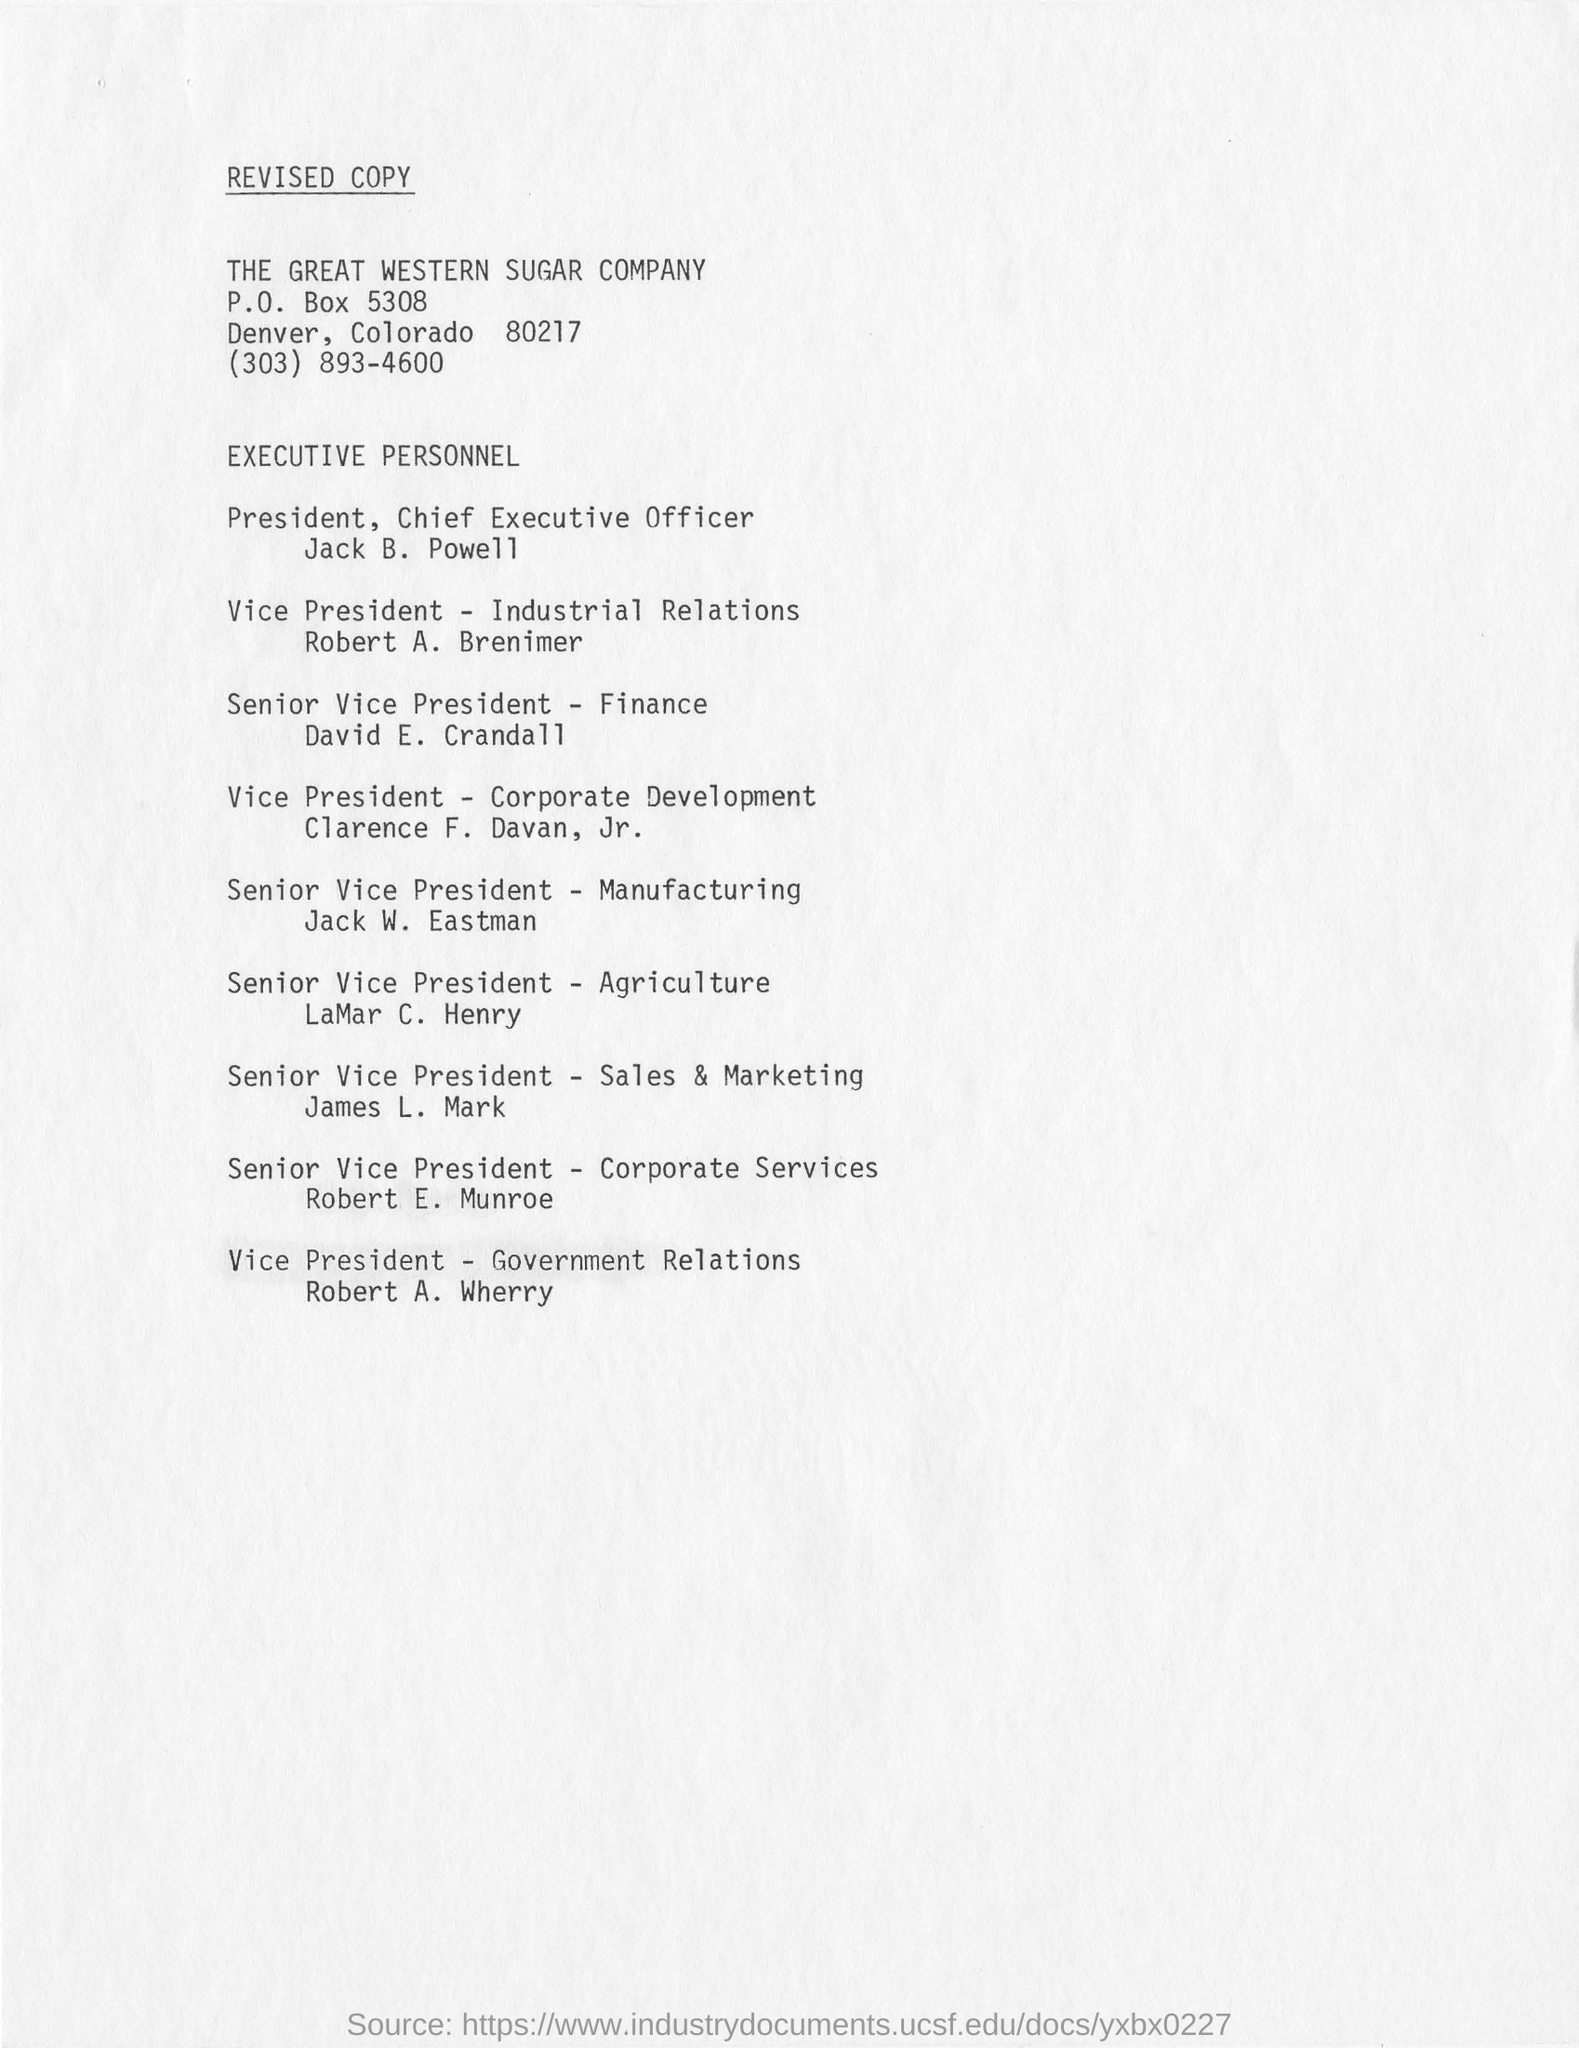Who is the senior vice president -finance ?
Your answer should be compact. David E. Crandall. Jack w. eastman the senior vice president belongs to which trade ?
Your answer should be compact. Manufacturing. Who is the vice president of corporate development ?
Provide a short and direct response. Clarence F. Davan, Jr. Who is the vice president of government relations ?
Provide a succinct answer. Robert  A. Wherry. Robert a. brenimer is the vice president of?
Your answer should be compact. Industrial Relations. Who is the senior vice president of sales and marketing ?
Give a very brief answer. James L. Mark. 